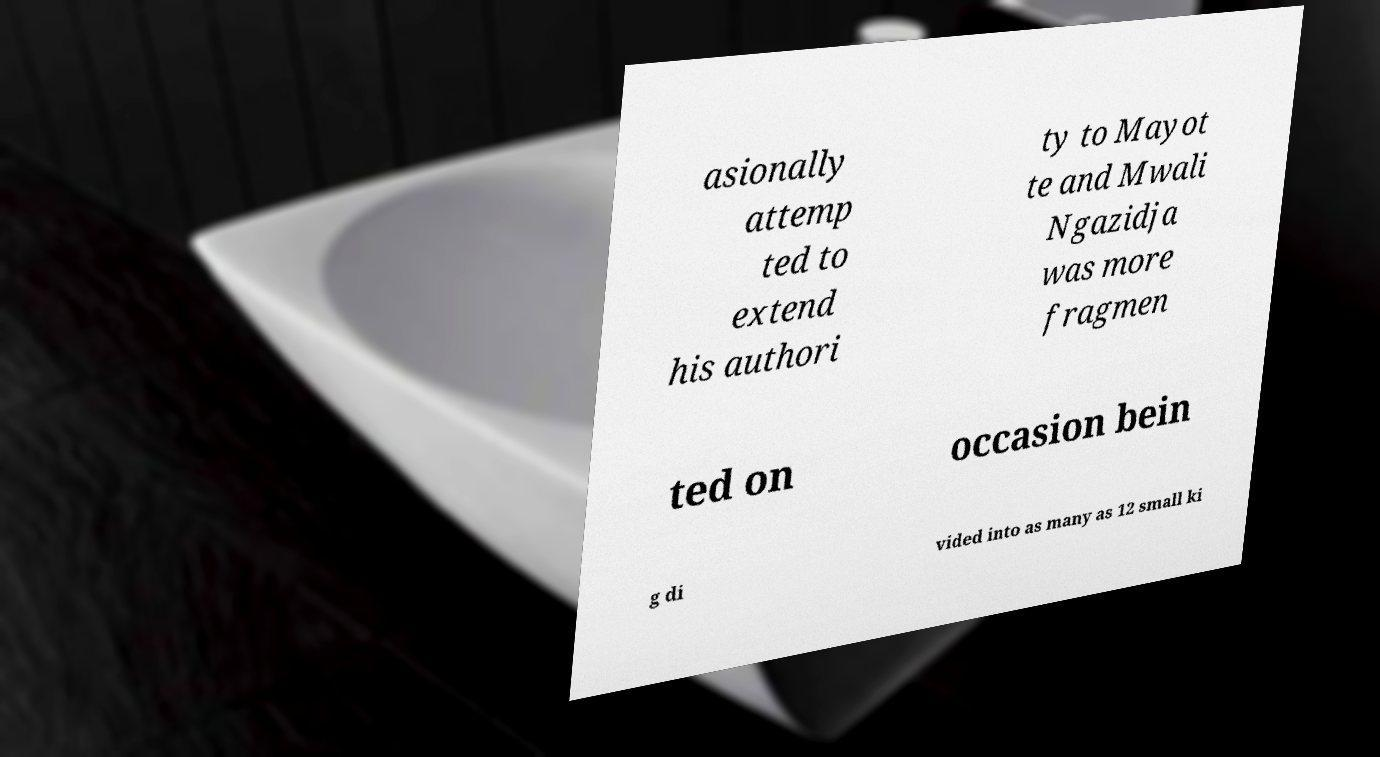Could you assist in decoding the text presented in this image and type it out clearly? asionally attemp ted to extend his authori ty to Mayot te and Mwali Ngazidja was more fragmen ted on occasion bein g di vided into as many as 12 small ki 